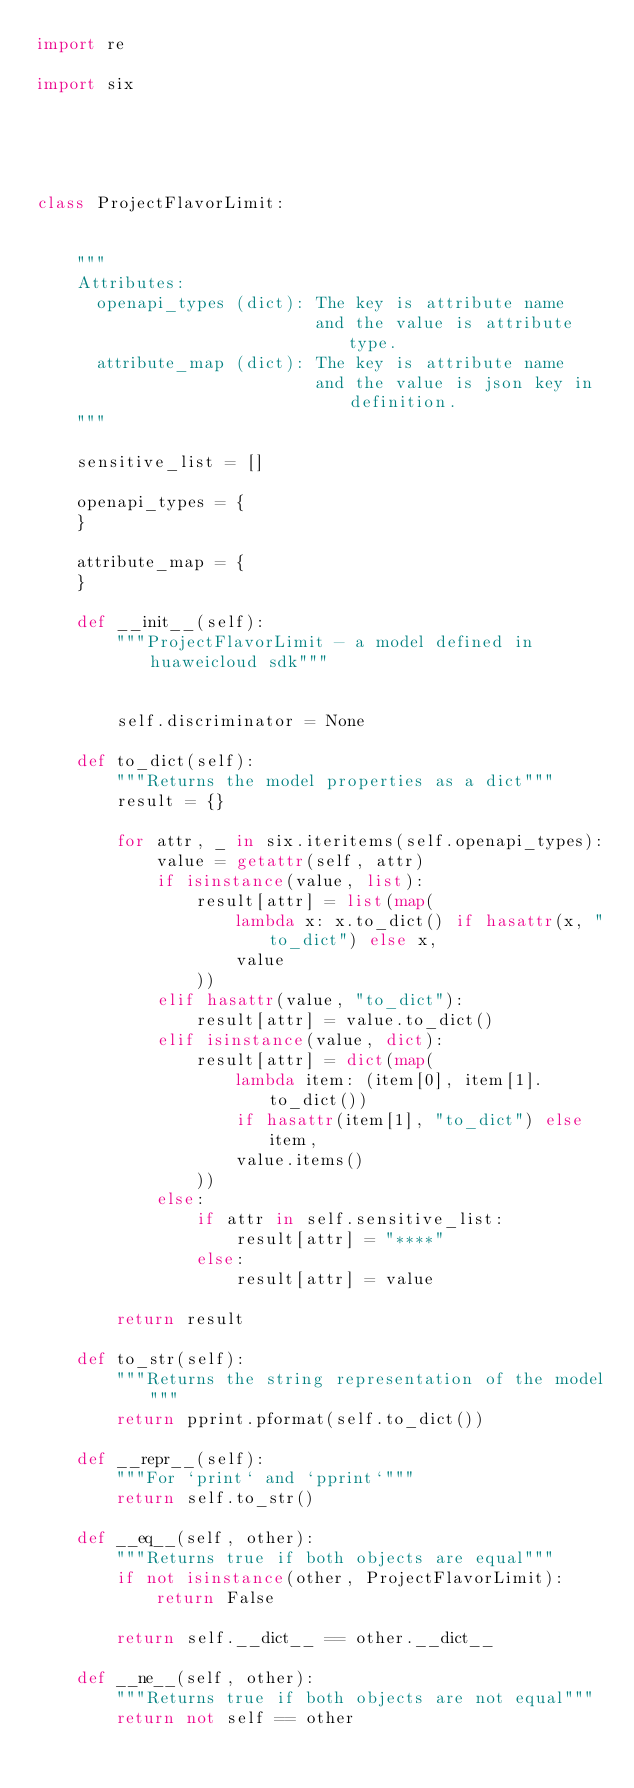Convert code to text. <code><loc_0><loc_0><loc_500><loc_500><_Python_>import re

import six





class ProjectFlavorLimit:


    """
    Attributes:
      openapi_types (dict): The key is attribute name
                            and the value is attribute type.
      attribute_map (dict): The key is attribute name
                            and the value is json key in definition.
    """

    sensitive_list = []

    openapi_types = {
    }

    attribute_map = {
    }

    def __init__(self):
        """ProjectFlavorLimit - a model defined in huaweicloud sdk"""
        
        
        self.discriminator = None

    def to_dict(self):
        """Returns the model properties as a dict"""
        result = {}

        for attr, _ in six.iteritems(self.openapi_types):
            value = getattr(self, attr)
            if isinstance(value, list):
                result[attr] = list(map(
                    lambda x: x.to_dict() if hasattr(x, "to_dict") else x,
                    value
                ))
            elif hasattr(value, "to_dict"):
                result[attr] = value.to_dict()
            elif isinstance(value, dict):
                result[attr] = dict(map(
                    lambda item: (item[0], item[1].to_dict())
                    if hasattr(item[1], "to_dict") else item,
                    value.items()
                ))
            else:
                if attr in self.sensitive_list:
                    result[attr] = "****"
                else:
                    result[attr] = value

        return result

    def to_str(self):
        """Returns the string representation of the model"""
        return pprint.pformat(self.to_dict())

    def __repr__(self):
        """For `print` and `pprint`"""
        return self.to_str()

    def __eq__(self, other):
        """Returns true if both objects are equal"""
        if not isinstance(other, ProjectFlavorLimit):
            return False

        return self.__dict__ == other.__dict__

    def __ne__(self, other):
        """Returns true if both objects are not equal"""
        return not self == other
</code> 